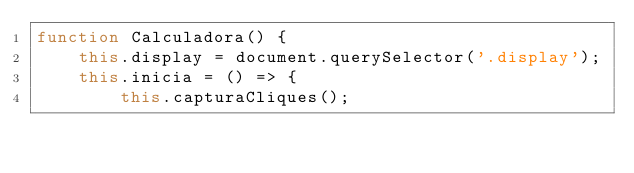<code> <loc_0><loc_0><loc_500><loc_500><_JavaScript_>function Calculadora() {
    this.display = document.querySelector('.display');
    this.inicia = () => {
        this.capturaCliques();</code> 